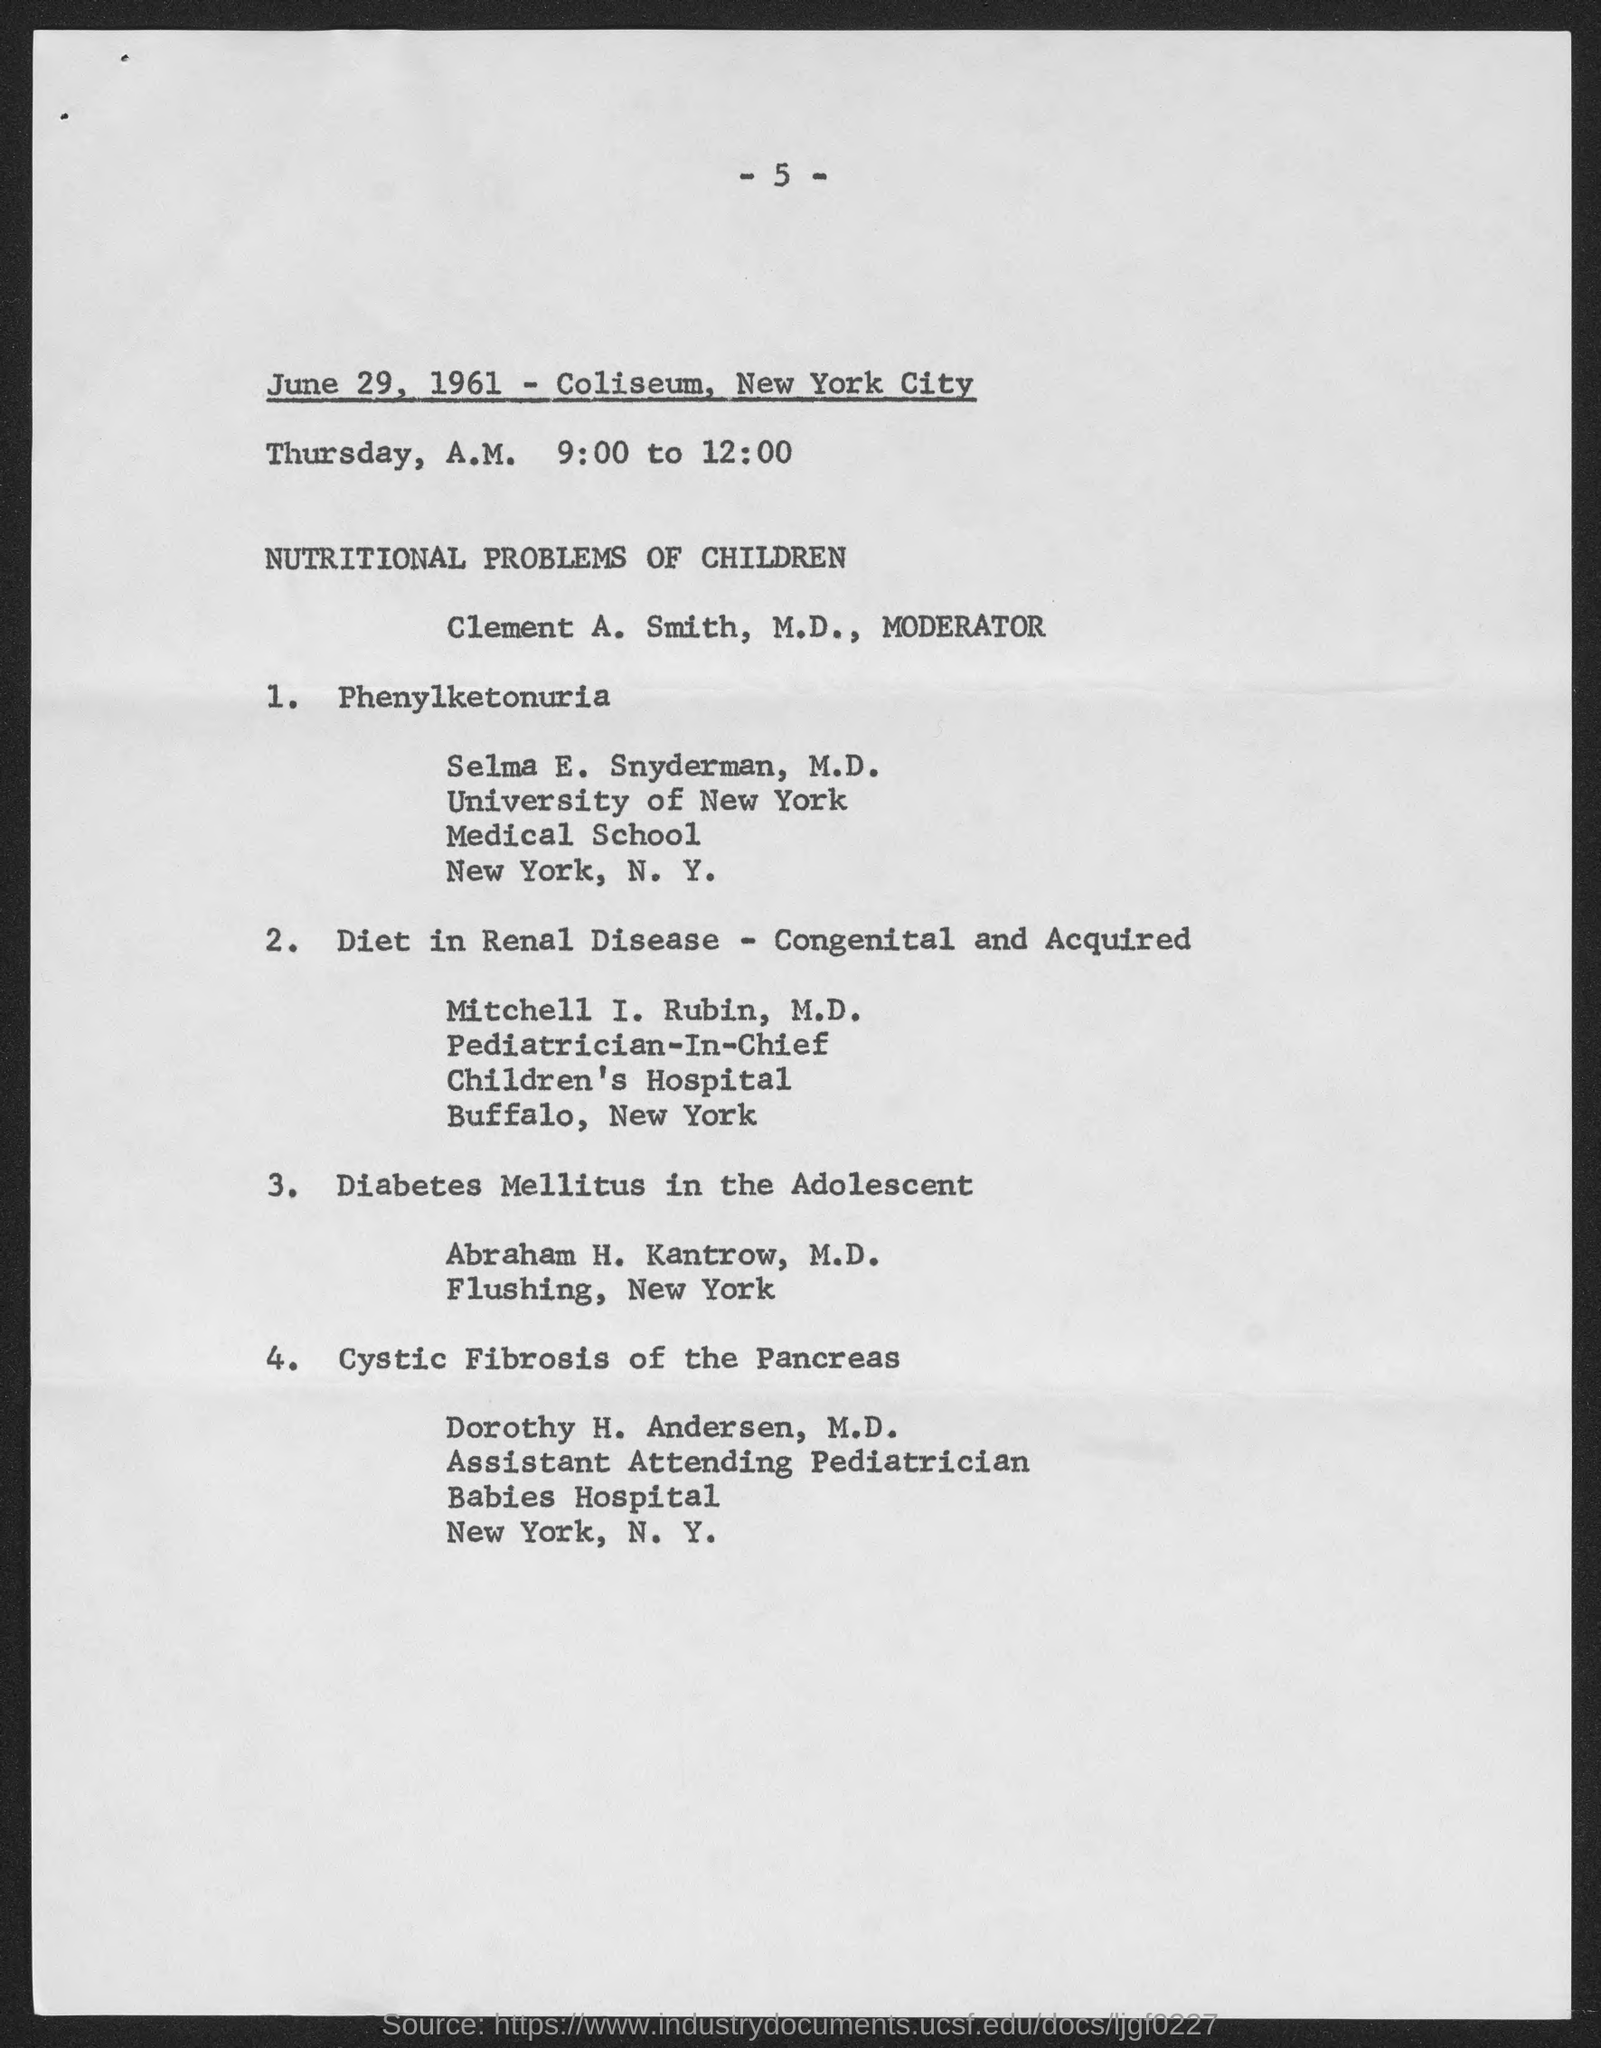When is the coliseum?
Provide a succinct answer. June 29, 1961. Where is the coliseum?
Offer a terse response. New york city. What is the coliseum about?
Give a very brief answer. Nutritional problems of children. 